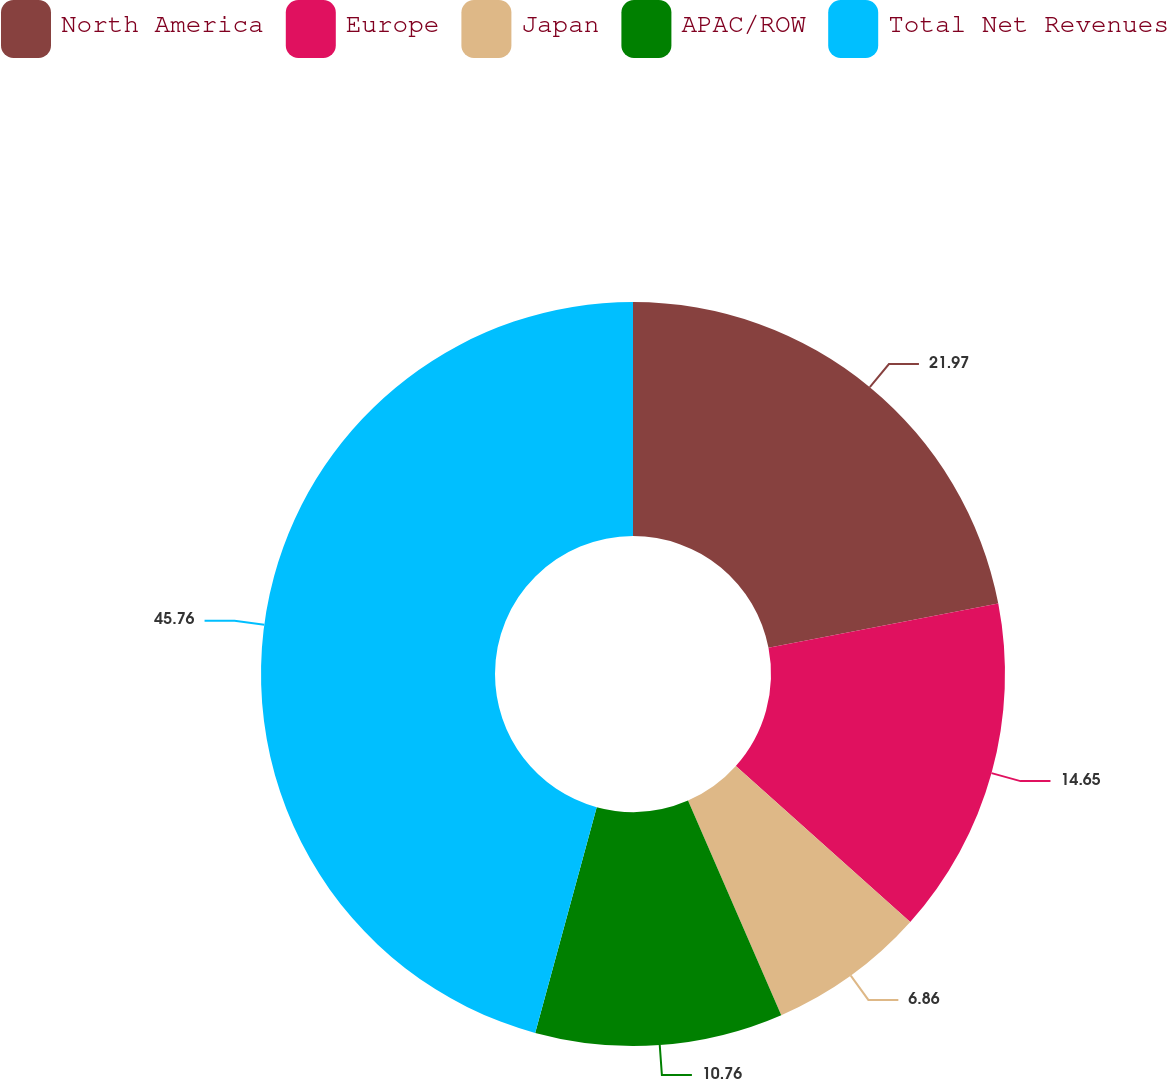Convert chart to OTSL. <chart><loc_0><loc_0><loc_500><loc_500><pie_chart><fcel>North America<fcel>Europe<fcel>Japan<fcel>APAC/ROW<fcel>Total Net Revenues<nl><fcel>21.97%<fcel>14.65%<fcel>6.86%<fcel>10.76%<fcel>45.77%<nl></chart> 